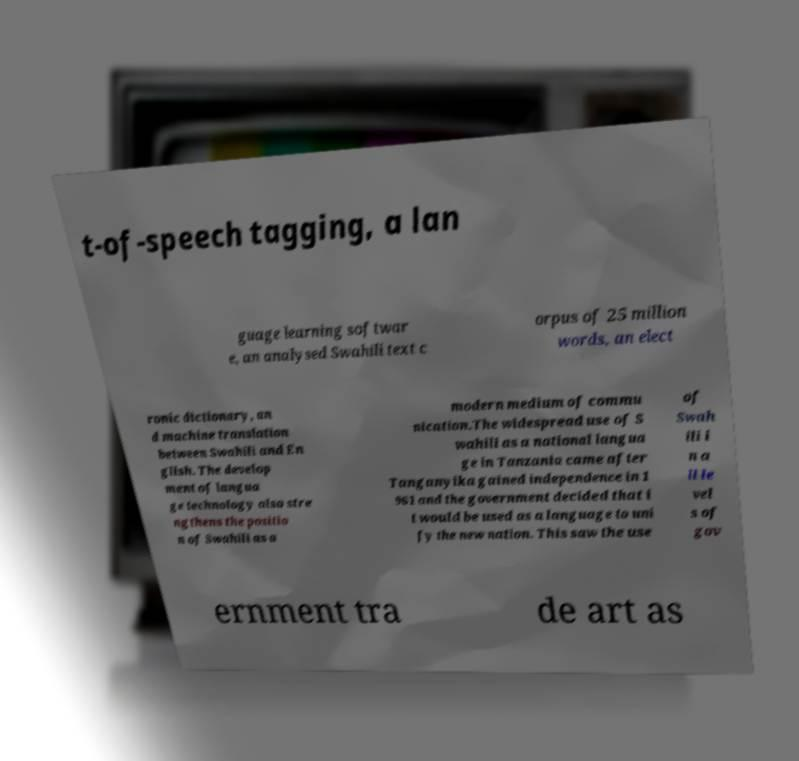Could you assist in decoding the text presented in this image and type it out clearly? t-of-speech tagging, a lan guage learning softwar e, an analysed Swahili text c orpus of 25 million words, an elect ronic dictionary, an d machine translation between Swahili and En glish. The develop ment of langua ge technology also stre ngthens the positio n of Swahili as a modern medium of commu nication.The widespread use of S wahili as a national langua ge in Tanzania came after Tanganyika gained independence in 1 961 and the government decided that i t would be used as a language to uni fy the new nation. This saw the use of Swah ili i n a ll le vel s of gov ernment tra de art as 